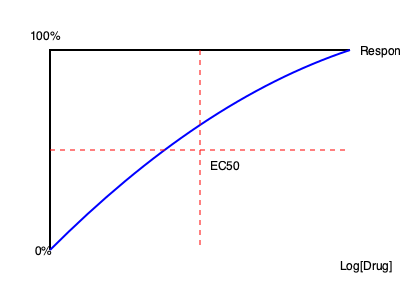In the dose-response curve shown above, what does the EC50 value represent, and how is it determined from the graph? To understand the EC50 value and its determination from the dose-response curve:

1. EC50 definition: The EC50 (half maximal effective concentration) is the concentration of a drug that produces 50% of its maximum effect.

2. Graphical representation:
   - The x-axis represents the logarithm of drug concentration.
   - The y-axis represents the drug response, typically from 0% to 100%.

3. Sigmoid curve: The blue curve is a typical sigmoid-shaped dose-response curve.

4. Locating 50% response:
   - The horizontal red dashed line indicates the 50% response level.

5. EC50 determination:
   - The vertical red dashed line intersects the curve at the 50% response point.
   - The x-coordinate of this intersection point corresponds to the log[EC50].

6. Reading the value:
   - Project the intersection point onto the x-axis.
   - The corresponding drug concentration is the EC50 value.

7. Interpretation:
   - The EC50 represents the drug concentration required to achieve half of the maximum observed effect.
   - It's a measure of drug potency: lower EC50 values indicate higher potency.

8. Practical use:
   - In drug development, EC50 is crucial for comparing the relative potencies of different compounds.
   - It helps in determining therapeutic doses and assessing drug efficacy.
Answer: EC50 is the drug concentration producing 50% of the maximum effect, determined by the x-axis value at the curve's midpoint. 